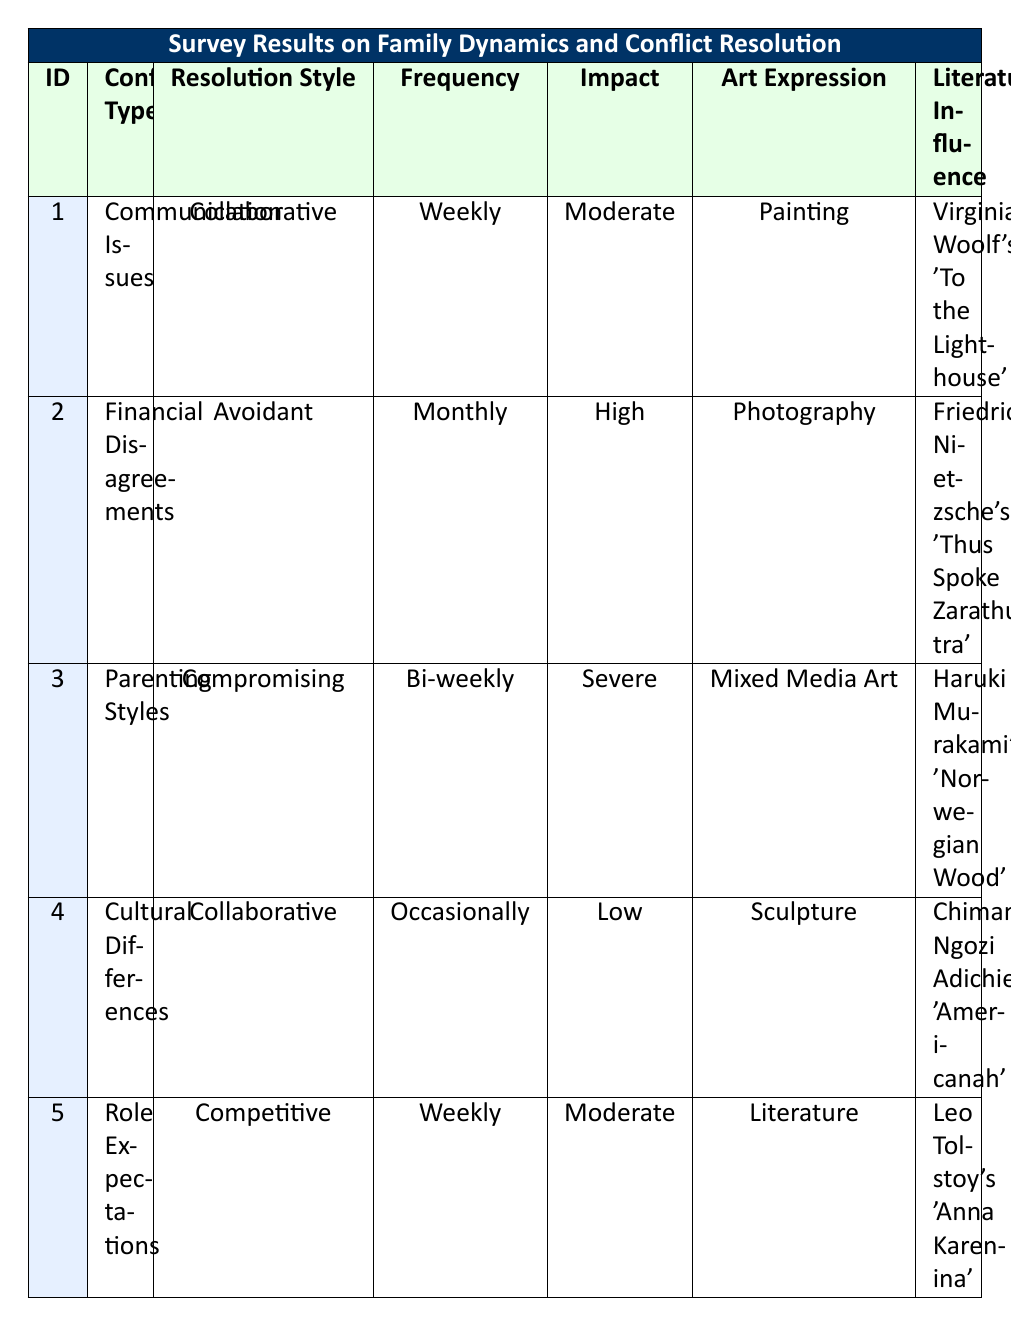What is the resolution style of participant 3? According to the table, participant 3 has a resolution style listed as "Compromising."
Answer: Compromising How many participants reported a high impact of conflict on their family? The table shows two participants (participant 2 and participant 3) reported a "High" impact on their family.
Answer: 2 What artistic expression was used by the participant who experiences role expectation conflicts? Participant 5 stated their artistic expression used is "Literature."
Answer: Literature Which participant has the highest frequency of conflict? Both participant 1 and participant 5 have a frequency of conflict listed as "Weekly," which is the highest frequency noted in the table.
Answer: Participant 1 and Participant 5 Is there any participant who has a collaborative resolution style? Yes, participants 1 and 4 both have a resolution style of "Collaborative."
Answer: Yes What is the average age of participants who reported communication issues and cultural differences? The ages of participants reporting these issues are 29 (Participant 1) and 27 (Participant 4). The average is (29 + 27) / 2 = 28.
Answer: 28 Who uses mixed media art as a form of artistic expression? Participant 3 is the only participant listed who uses "Mixed Media Art" as their artistic expression.
Answer: Participant 3 Which literary influence is associated with the participant who experiences parenting style conflicts? Participant 3 is influenced by Haruki Murakami's "Norwegian Wood" regarding parenting style conflicts.
Answer: Haruki Murakami's "Norwegian Wood" What is the ratio of participants using collaborative versus avoidant resolution styles? There are two participants using "Collaborative" (participants 1 and 4) and one using "Avoidant" (participant 2), giving a ratio of 2:1.
Answer: 2:1 